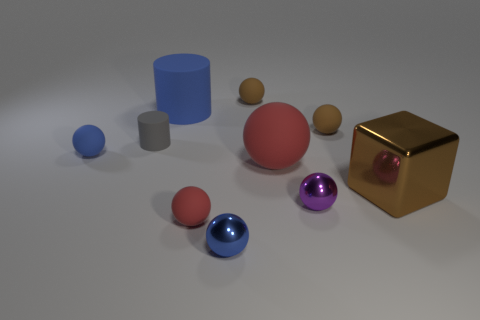There is a big cube; is it the same color as the small matte sphere that is behind the blue cylinder?
Ensure brevity in your answer.  Yes. Is there any other thing that is the same shape as the small red matte object?
Give a very brief answer. Yes. There is a small matte ball on the right side of the brown thing that is behind the blue cylinder; what is its color?
Your response must be concise. Brown. What number of tiny blue metal objects are there?
Your answer should be very brief. 1. What number of matte objects are tiny brown things or tiny cyan things?
Keep it short and to the point. 2. What number of tiny metal objects are the same color as the large cylinder?
Offer a terse response. 1. There is a blue sphere in front of the large red matte ball to the left of the small purple metal ball; what is it made of?
Your answer should be compact. Metal. How big is the brown cube?
Offer a very short reply. Large. How many blue objects have the same size as the cube?
Provide a succinct answer. 1. What number of small objects have the same shape as the big brown thing?
Keep it short and to the point. 0. 